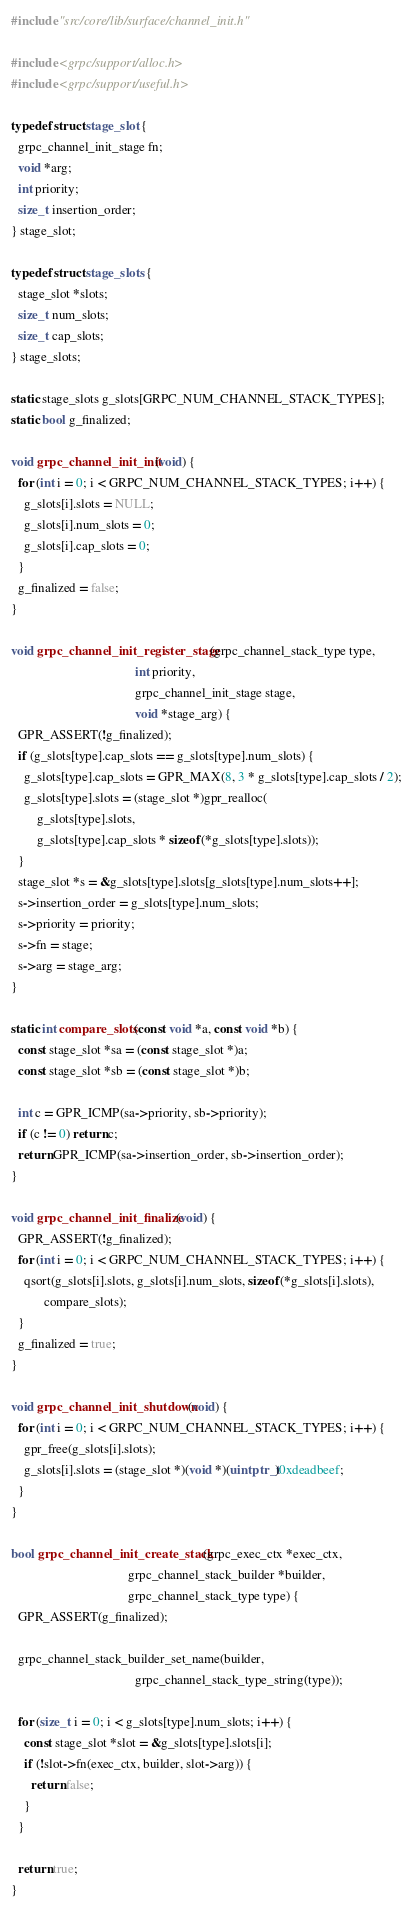<code> <loc_0><loc_0><loc_500><loc_500><_C_>
#include "src/core/lib/surface/channel_init.h"

#include <grpc/support/alloc.h>
#include <grpc/support/useful.h>

typedef struct stage_slot {
  grpc_channel_init_stage fn;
  void *arg;
  int priority;
  size_t insertion_order;
} stage_slot;

typedef struct stage_slots {
  stage_slot *slots;
  size_t num_slots;
  size_t cap_slots;
} stage_slots;

static stage_slots g_slots[GRPC_NUM_CHANNEL_STACK_TYPES];
static bool g_finalized;

void grpc_channel_init_init(void) {
  for (int i = 0; i < GRPC_NUM_CHANNEL_STACK_TYPES; i++) {
    g_slots[i].slots = NULL;
    g_slots[i].num_slots = 0;
    g_slots[i].cap_slots = 0;
  }
  g_finalized = false;
}

void grpc_channel_init_register_stage(grpc_channel_stack_type type,
                                      int priority,
                                      grpc_channel_init_stage stage,
                                      void *stage_arg) {
  GPR_ASSERT(!g_finalized);
  if (g_slots[type].cap_slots == g_slots[type].num_slots) {
    g_slots[type].cap_slots = GPR_MAX(8, 3 * g_slots[type].cap_slots / 2);
    g_slots[type].slots = (stage_slot *)gpr_realloc(
        g_slots[type].slots,
        g_slots[type].cap_slots * sizeof(*g_slots[type].slots));
  }
  stage_slot *s = &g_slots[type].slots[g_slots[type].num_slots++];
  s->insertion_order = g_slots[type].num_slots;
  s->priority = priority;
  s->fn = stage;
  s->arg = stage_arg;
}

static int compare_slots(const void *a, const void *b) {
  const stage_slot *sa = (const stage_slot *)a;
  const stage_slot *sb = (const stage_slot *)b;

  int c = GPR_ICMP(sa->priority, sb->priority);
  if (c != 0) return c;
  return GPR_ICMP(sa->insertion_order, sb->insertion_order);
}

void grpc_channel_init_finalize(void) {
  GPR_ASSERT(!g_finalized);
  for (int i = 0; i < GRPC_NUM_CHANNEL_STACK_TYPES; i++) {
    qsort(g_slots[i].slots, g_slots[i].num_slots, sizeof(*g_slots[i].slots),
          compare_slots);
  }
  g_finalized = true;
}

void grpc_channel_init_shutdown(void) {
  for (int i = 0; i < GRPC_NUM_CHANNEL_STACK_TYPES; i++) {
    gpr_free(g_slots[i].slots);
    g_slots[i].slots = (stage_slot *)(void *)(uintptr_t)0xdeadbeef;
  }
}

bool grpc_channel_init_create_stack(grpc_exec_ctx *exec_ctx,
                                    grpc_channel_stack_builder *builder,
                                    grpc_channel_stack_type type) {
  GPR_ASSERT(g_finalized);

  grpc_channel_stack_builder_set_name(builder,
                                      grpc_channel_stack_type_string(type));

  for (size_t i = 0; i < g_slots[type].num_slots; i++) {
    const stage_slot *slot = &g_slots[type].slots[i];
    if (!slot->fn(exec_ctx, builder, slot->arg)) {
      return false;
    }
  }

  return true;
}
</code> 